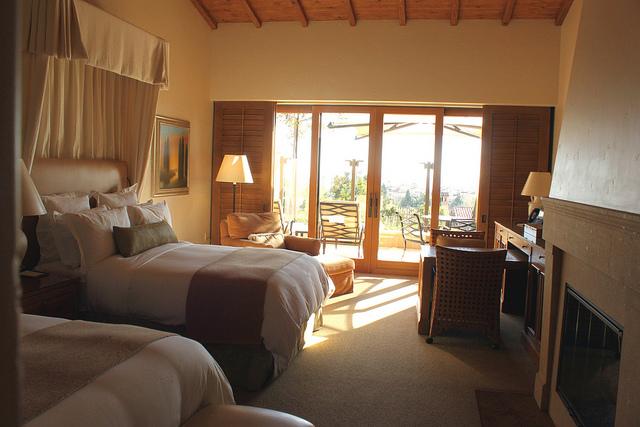Is this room esthetically pleasing?
Be succinct. Yes. How many picture frames are above the window?
Be succinct. 0. What material is the fireplace made of?
Answer briefly. Wood. Is this someone's apartment?
Be succinct. No. What is hanging over the bed?
Concise answer only. Curtain. How many pillows on the bed?
Give a very brief answer. 5. Is there a shelf on the fireplace?
Keep it brief. No. How many different color pillows are there?
Be succinct. 2. How many beds are in this room?
Keep it brief. 2. Is this room on the ground floor?
Concise answer only. Yes. Do the pillows match?
Short answer required. Yes. Is the bed made?
Be succinct. Yes. What is located under the window?
Answer briefly. Chair. 